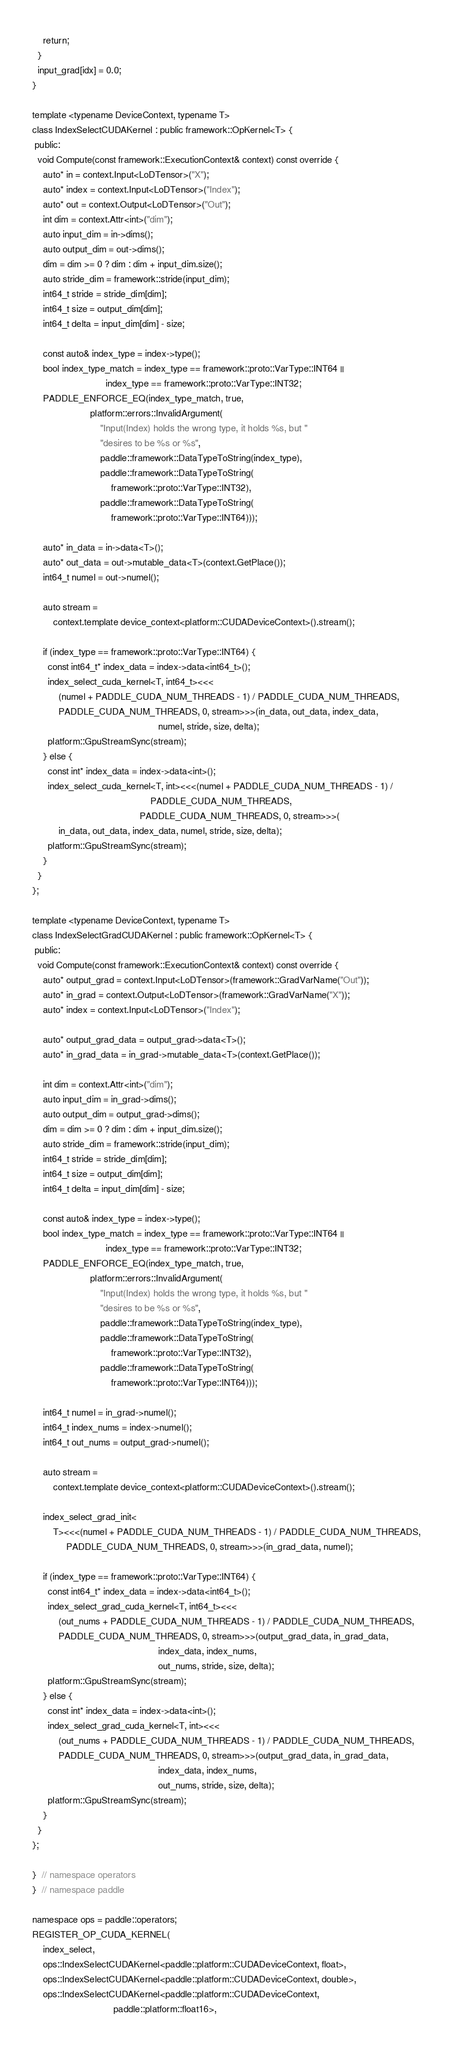<code> <loc_0><loc_0><loc_500><loc_500><_Cuda_>    return;
  }
  input_grad[idx] = 0.0;
}

template <typename DeviceContext, typename T>
class IndexSelectCUDAKernel : public framework::OpKernel<T> {
 public:
  void Compute(const framework::ExecutionContext& context) const override {
    auto* in = context.Input<LoDTensor>("X");
    auto* index = context.Input<LoDTensor>("Index");
    auto* out = context.Output<LoDTensor>("Out");
    int dim = context.Attr<int>("dim");
    auto input_dim = in->dims();
    auto output_dim = out->dims();
    dim = dim >= 0 ? dim : dim + input_dim.size();
    auto stride_dim = framework::stride(input_dim);
    int64_t stride = stride_dim[dim];
    int64_t size = output_dim[dim];
    int64_t delta = input_dim[dim] - size;

    const auto& index_type = index->type();
    bool index_type_match = index_type == framework::proto::VarType::INT64 ||
                            index_type == framework::proto::VarType::INT32;
    PADDLE_ENFORCE_EQ(index_type_match, true,
                      platform::errors::InvalidArgument(
                          "Input(Index) holds the wrong type, it holds %s, but "
                          "desires to be %s or %s",
                          paddle::framework::DataTypeToString(index_type),
                          paddle::framework::DataTypeToString(
                              framework::proto::VarType::INT32),
                          paddle::framework::DataTypeToString(
                              framework::proto::VarType::INT64)));

    auto* in_data = in->data<T>();
    auto* out_data = out->mutable_data<T>(context.GetPlace());
    int64_t numel = out->numel();

    auto stream =
        context.template device_context<platform::CUDADeviceContext>().stream();

    if (index_type == framework::proto::VarType::INT64) {
      const int64_t* index_data = index->data<int64_t>();
      index_select_cuda_kernel<T, int64_t><<<
          (numel + PADDLE_CUDA_NUM_THREADS - 1) / PADDLE_CUDA_NUM_THREADS,
          PADDLE_CUDA_NUM_THREADS, 0, stream>>>(in_data, out_data, index_data,
                                                numel, stride, size, delta);
      platform::GpuStreamSync(stream);
    } else {
      const int* index_data = index->data<int>();
      index_select_cuda_kernel<T, int><<<(numel + PADDLE_CUDA_NUM_THREADS - 1) /
                                             PADDLE_CUDA_NUM_THREADS,
                                         PADDLE_CUDA_NUM_THREADS, 0, stream>>>(
          in_data, out_data, index_data, numel, stride, size, delta);
      platform::GpuStreamSync(stream);
    }
  }
};

template <typename DeviceContext, typename T>
class IndexSelectGradCUDAKernel : public framework::OpKernel<T> {
 public:
  void Compute(const framework::ExecutionContext& context) const override {
    auto* output_grad = context.Input<LoDTensor>(framework::GradVarName("Out"));
    auto* in_grad = context.Output<LoDTensor>(framework::GradVarName("X"));
    auto* index = context.Input<LoDTensor>("Index");

    auto* output_grad_data = output_grad->data<T>();
    auto* in_grad_data = in_grad->mutable_data<T>(context.GetPlace());

    int dim = context.Attr<int>("dim");
    auto input_dim = in_grad->dims();
    auto output_dim = output_grad->dims();
    dim = dim >= 0 ? dim : dim + input_dim.size();
    auto stride_dim = framework::stride(input_dim);
    int64_t stride = stride_dim[dim];
    int64_t size = output_dim[dim];
    int64_t delta = input_dim[dim] - size;

    const auto& index_type = index->type();
    bool index_type_match = index_type == framework::proto::VarType::INT64 ||
                            index_type == framework::proto::VarType::INT32;
    PADDLE_ENFORCE_EQ(index_type_match, true,
                      platform::errors::InvalidArgument(
                          "Input(Index) holds the wrong type, it holds %s, but "
                          "desires to be %s or %s",
                          paddle::framework::DataTypeToString(index_type),
                          paddle::framework::DataTypeToString(
                              framework::proto::VarType::INT32),
                          paddle::framework::DataTypeToString(
                              framework::proto::VarType::INT64)));

    int64_t numel = in_grad->numel();
    int64_t index_nums = index->numel();
    int64_t out_nums = output_grad->numel();

    auto stream =
        context.template device_context<platform::CUDADeviceContext>().stream();

    index_select_grad_init<
        T><<<(numel + PADDLE_CUDA_NUM_THREADS - 1) / PADDLE_CUDA_NUM_THREADS,
             PADDLE_CUDA_NUM_THREADS, 0, stream>>>(in_grad_data, numel);

    if (index_type == framework::proto::VarType::INT64) {
      const int64_t* index_data = index->data<int64_t>();
      index_select_grad_cuda_kernel<T, int64_t><<<
          (out_nums + PADDLE_CUDA_NUM_THREADS - 1) / PADDLE_CUDA_NUM_THREADS,
          PADDLE_CUDA_NUM_THREADS, 0, stream>>>(output_grad_data, in_grad_data,
                                                index_data, index_nums,
                                                out_nums, stride, size, delta);
      platform::GpuStreamSync(stream);
    } else {
      const int* index_data = index->data<int>();
      index_select_grad_cuda_kernel<T, int><<<
          (out_nums + PADDLE_CUDA_NUM_THREADS - 1) / PADDLE_CUDA_NUM_THREADS,
          PADDLE_CUDA_NUM_THREADS, 0, stream>>>(output_grad_data, in_grad_data,
                                                index_data, index_nums,
                                                out_nums, stride, size, delta);
      platform::GpuStreamSync(stream);
    }
  }
};

}  // namespace operators
}  // namespace paddle

namespace ops = paddle::operators;
REGISTER_OP_CUDA_KERNEL(
    index_select,
    ops::IndexSelectCUDAKernel<paddle::platform::CUDADeviceContext, float>,
    ops::IndexSelectCUDAKernel<paddle::platform::CUDADeviceContext, double>,
    ops::IndexSelectCUDAKernel<paddle::platform::CUDADeviceContext,
                               paddle::platform::float16>,</code> 